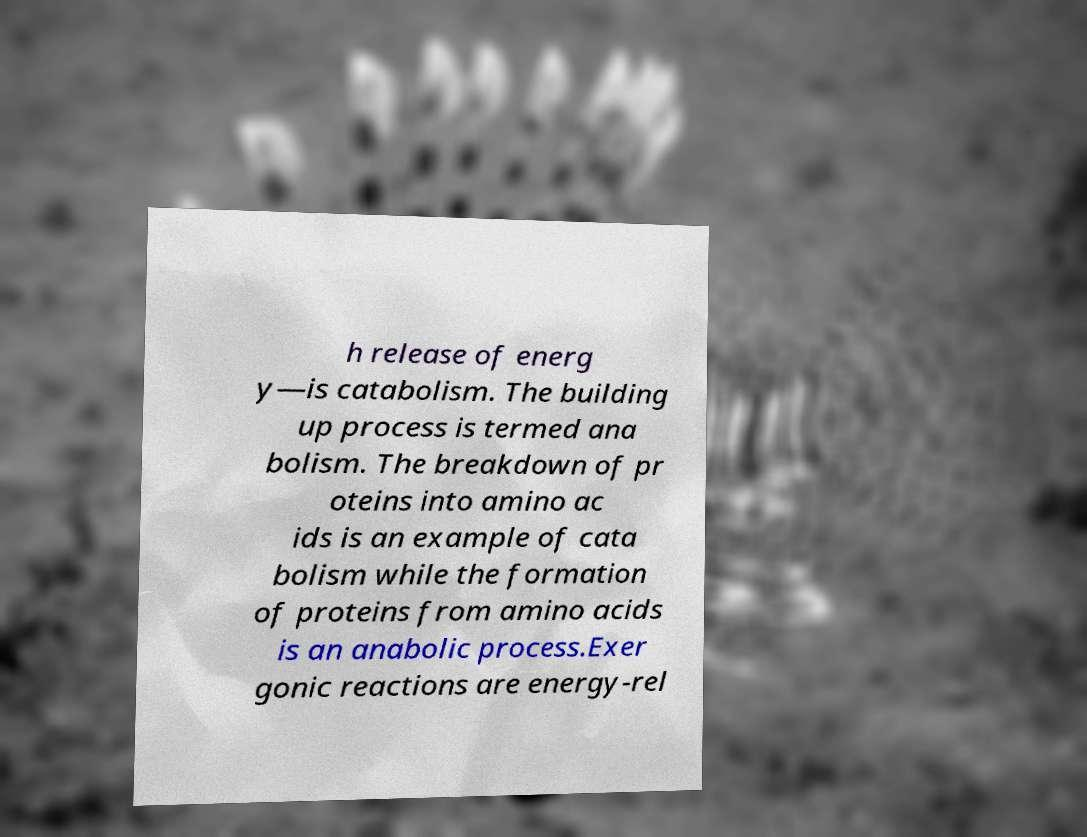What messages or text are displayed in this image? I need them in a readable, typed format. h release of energ y—is catabolism. The building up process is termed ana bolism. The breakdown of pr oteins into amino ac ids is an example of cata bolism while the formation of proteins from amino acids is an anabolic process.Exer gonic reactions are energy-rel 